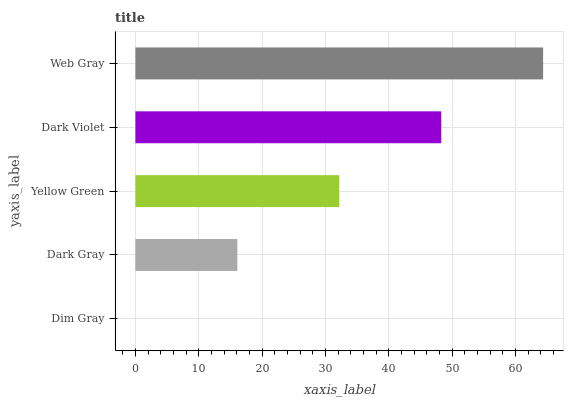Is Dim Gray the minimum?
Answer yes or no. Yes. Is Web Gray the maximum?
Answer yes or no. Yes. Is Dark Gray the minimum?
Answer yes or no. No. Is Dark Gray the maximum?
Answer yes or no. No. Is Dark Gray greater than Dim Gray?
Answer yes or no. Yes. Is Dim Gray less than Dark Gray?
Answer yes or no. Yes. Is Dim Gray greater than Dark Gray?
Answer yes or no. No. Is Dark Gray less than Dim Gray?
Answer yes or no. No. Is Yellow Green the high median?
Answer yes or no. Yes. Is Yellow Green the low median?
Answer yes or no. Yes. Is Dark Gray the high median?
Answer yes or no. No. Is Dark Gray the low median?
Answer yes or no. No. 